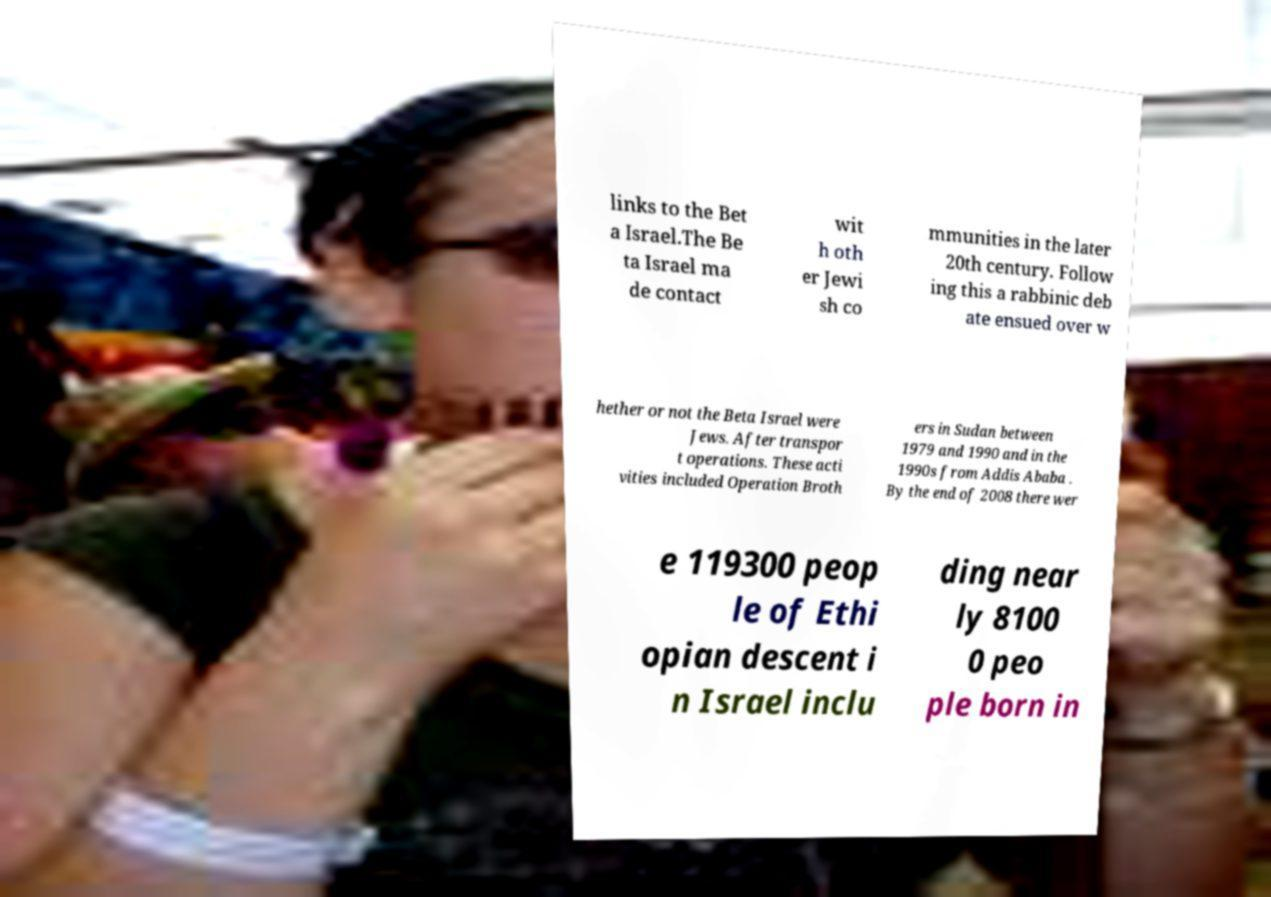Please identify and transcribe the text found in this image. links to the Bet a Israel.The Be ta Israel ma de contact wit h oth er Jewi sh co mmunities in the later 20th century. Follow ing this a rabbinic deb ate ensued over w hether or not the Beta Israel were Jews. After transpor t operations. These acti vities included Operation Broth ers in Sudan between 1979 and 1990 and in the 1990s from Addis Ababa . By the end of 2008 there wer e 119300 peop le of Ethi opian descent i n Israel inclu ding near ly 8100 0 peo ple born in 